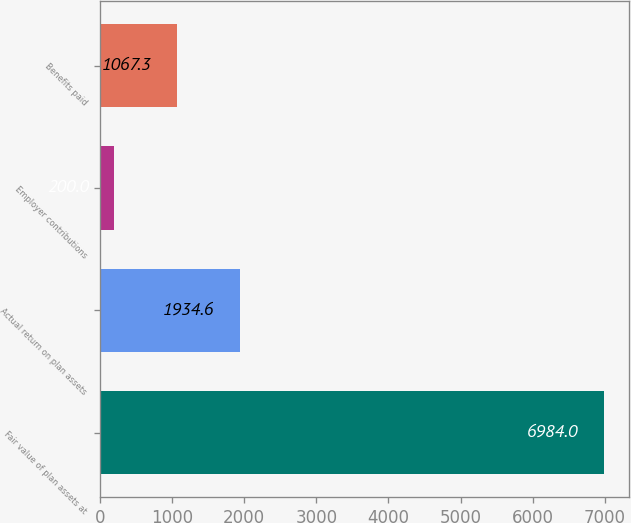<chart> <loc_0><loc_0><loc_500><loc_500><bar_chart><fcel>Fair value of plan assets at<fcel>Actual return on plan assets<fcel>Employer contributions<fcel>Benefits paid<nl><fcel>6984<fcel>1934.6<fcel>200<fcel>1067.3<nl></chart> 